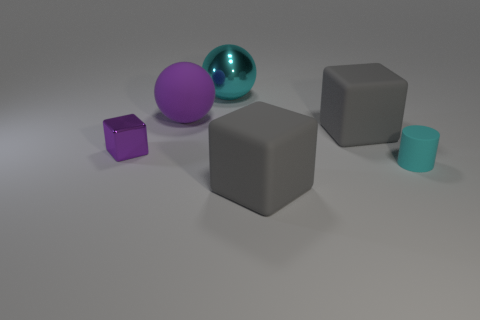Subtract all purple cylinders. Subtract all yellow blocks. How many cylinders are left? 1 Add 2 matte things. How many objects exist? 8 Subtract all cylinders. How many objects are left? 5 Add 2 large balls. How many large balls exist? 4 Subtract 1 purple blocks. How many objects are left? 5 Subtract all big balls. Subtract all tiny purple rubber cylinders. How many objects are left? 4 Add 3 matte blocks. How many matte blocks are left? 5 